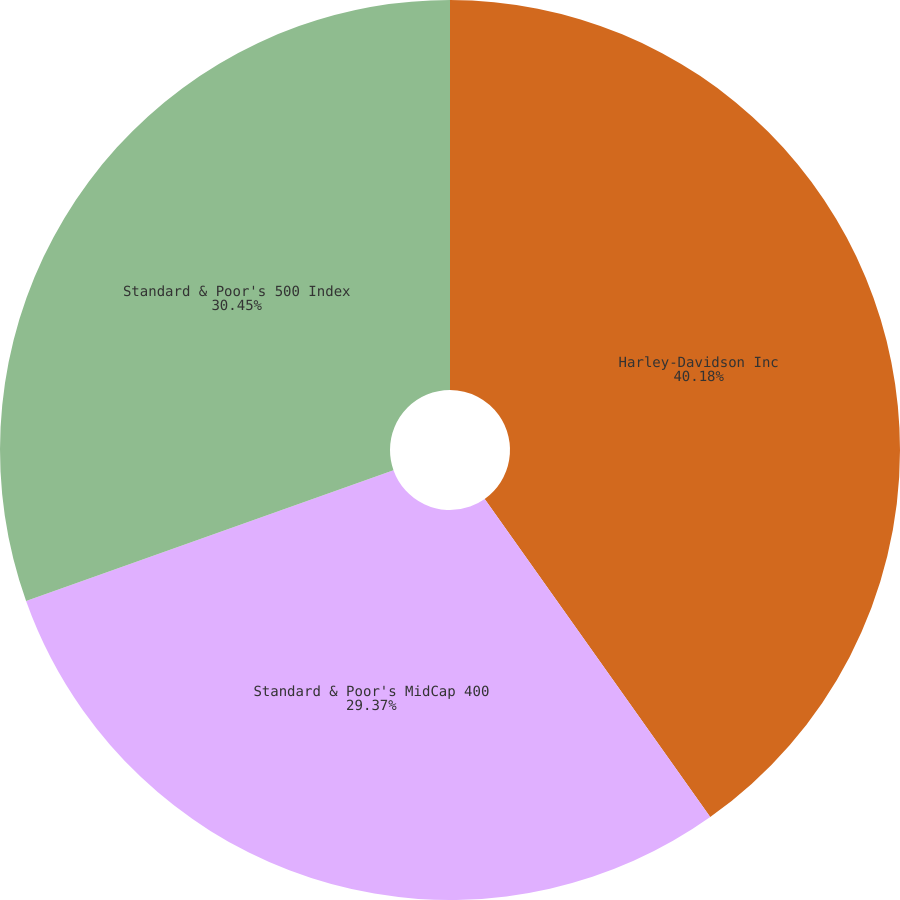Convert chart to OTSL. <chart><loc_0><loc_0><loc_500><loc_500><pie_chart><fcel>Harley-Davidson Inc<fcel>Standard & Poor's MidCap 400<fcel>Standard & Poor's 500 Index<nl><fcel>40.19%<fcel>29.37%<fcel>30.45%<nl></chart> 